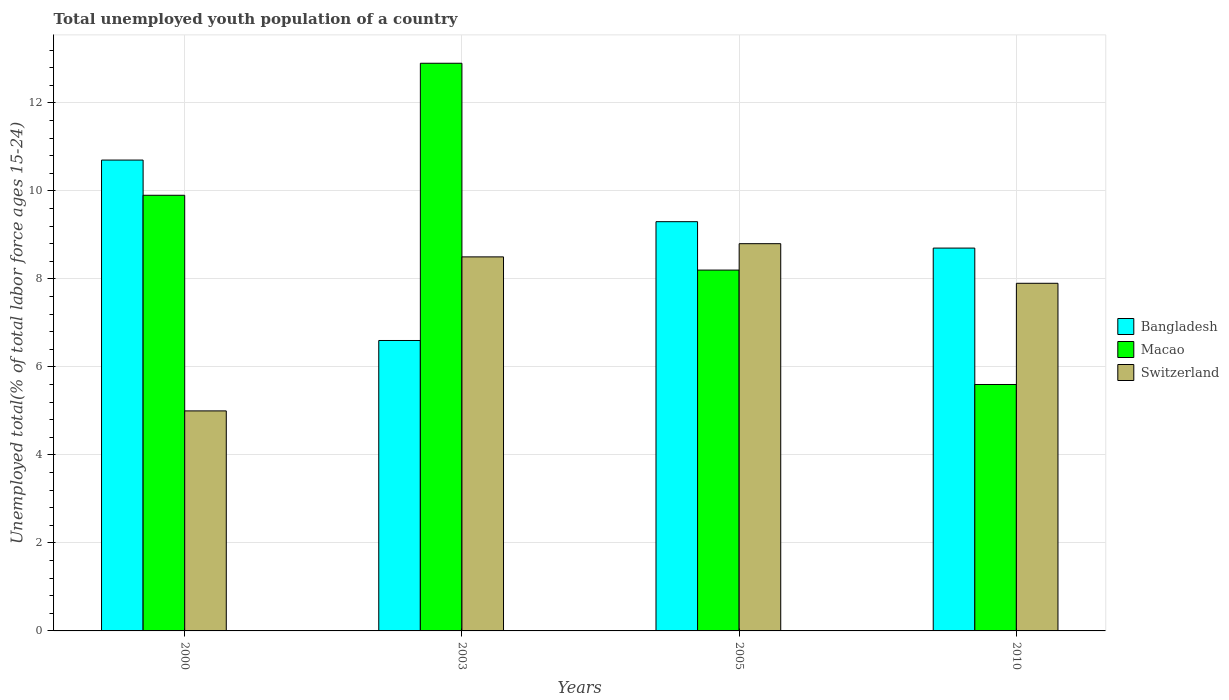How many different coloured bars are there?
Provide a short and direct response. 3. Are the number of bars per tick equal to the number of legend labels?
Provide a short and direct response. Yes. What is the percentage of total unemployed youth population of a country in Switzerland in 2003?
Your response must be concise. 8.5. Across all years, what is the maximum percentage of total unemployed youth population of a country in Switzerland?
Keep it short and to the point. 8.8. Across all years, what is the minimum percentage of total unemployed youth population of a country in Bangladesh?
Provide a short and direct response. 6.6. In which year was the percentage of total unemployed youth population of a country in Switzerland minimum?
Your answer should be very brief. 2000. What is the total percentage of total unemployed youth population of a country in Macao in the graph?
Your response must be concise. 36.6. What is the difference between the percentage of total unemployed youth population of a country in Macao in 2000 and that in 2005?
Provide a succinct answer. 1.7. What is the difference between the percentage of total unemployed youth population of a country in Macao in 2000 and the percentage of total unemployed youth population of a country in Switzerland in 2010?
Provide a succinct answer. 2. What is the average percentage of total unemployed youth population of a country in Switzerland per year?
Provide a succinct answer. 7.55. In the year 2003, what is the difference between the percentage of total unemployed youth population of a country in Bangladesh and percentage of total unemployed youth population of a country in Switzerland?
Keep it short and to the point. -1.9. In how many years, is the percentage of total unemployed youth population of a country in Switzerland greater than 5.6 %?
Provide a succinct answer. 3. What is the ratio of the percentage of total unemployed youth population of a country in Macao in 2000 to that in 2010?
Your response must be concise. 1.77. What is the difference between the highest and the second highest percentage of total unemployed youth population of a country in Bangladesh?
Provide a succinct answer. 1.4. What is the difference between the highest and the lowest percentage of total unemployed youth population of a country in Switzerland?
Offer a very short reply. 3.8. What does the 1st bar from the left in 2005 represents?
Your answer should be very brief. Bangladesh. What does the 2nd bar from the right in 2005 represents?
Provide a succinct answer. Macao. How many bars are there?
Offer a terse response. 12. Are all the bars in the graph horizontal?
Offer a terse response. No. Does the graph contain any zero values?
Your response must be concise. No. Does the graph contain grids?
Offer a terse response. Yes. Where does the legend appear in the graph?
Offer a very short reply. Center right. How are the legend labels stacked?
Give a very brief answer. Vertical. What is the title of the graph?
Ensure brevity in your answer.  Total unemployed youth population of a country. What is the label or title of the X-axis?
Provide a succinct answer. Years. What is the label or title of the Y-axis?
Ensure brevity in your answer.  Unemployed total(% of total labor force ages 15-24). What is the Unemployed total(% of total labor force ages 15-24) of Bangladesh in 2000?
Your answer should be compact. 10.7. What is the Unemployed total(% of total labor force ages 15-24) of Macao in 2000?
Keep it short and to the point. 9.9. What is the Unemployed total(% of total labor force ages 15-24) in Switzerland in 2000?
Offer a terse response. 5. What is the Unemployed total(% of total labor force ages 15-24) of Bangladesh in 2003?
Your answer should be very brief. 6.6. What is the Unemployed total(% of total labor force ages 15-24) of Macao in 2003?
Ensure brevity in your answer.  12.9. What is the Unemployed total(% of total labor force ages 15-24) of Bangladesh in 2005?
Your answer should be compact. 9.3. What is the Unemployed total(% of total labor force ages 15-24) of Macao in 2005?
Your answer should be very brief. 8.2. What is the Unemployed total(% of total labor force ages 15-24) in Switzerland in 2005?
Provide a short and direct response. 8.8. What is the Unemployed total(% of total labor force ages 15-24) of Bangladesh in 2010?
Give a very brief answer. 8.7. What is the Unemployed total(% of total labor force ages 15-24) in Macao in 2010?
Provide a short and direct response. 5.6. What is the Unemployed total(% of total labor force ages 15-24) in Switzerland in 2010?
Provide a short and direct response. 7.9. Across all years, what is the maximum Unemployed total(% of total labor force ages 15-24) of Bangladesh?
Keep it short and to the point. 10.7. Across all years, what is the maximum Unemployed total(% of total labor force ages 15-24) in Macao?
Provide a succinct answer. 12.9. Across all years, what is the maximum Unemployed total(% of total labor force ages 15-24) of Switzerland?
Offer a terse response. 8.8. Across all years, what is the minimum Unemployed total(% of total labor force ages 15-24) of Bangladesh?
Make the answer very short. 6.6. Across all years, what is the minimum Unemployed total(% of total labor force ages 15-24) in Macao?
Offer a very short reply. 5.6. Across all years, what is the minimum Unemployed total(% of total labor force ages 15-24) in Switzerland?
Offer a very short reply. 5. What is the total Unemployed total(% of total labor force ages 15-24) in Bangladesh in the graph?
Make the answer very short. 35.3. What is the total Unemployed total(% of total labor force ages 15-24) in Macao in the graph?
Your answer should be very brief. 36.6. What is the total Unemployed total(% of total labor force ages 15-24) in Switzerland in the graph?
Provide a succinct answer. 30.2. What is the difference between the Unemployed total(% of total labor force ages 15-24) of Bangladesh in 2000 and that in 2005?
Provide a succinct answer. 1.4. What is the difference between the Unemployed total(% of total labor force ages 15-24) of Macao in 2000 and that in 2005?
Your response must be concise. 1.7. What is the difference between the Unemployed total(% of total labor force ages 15-24) in Switzerland in 2000 and that in 2005?
Ensure brevity in your answer.  -3.8. What is the difference between the Unemployed total(% of total labor force ages 15-24) of Bangladesh in 2000 and that in 2010?
Offer a very short reply. 2. What is the difference between the Unemployed total(% of total labor force ages 15-24) in Macao in 2000 and that in 2010?
Offer a terse response. 4.3. What is the difference between the Unemployed total(% of total labor force ages 15-24) of Switzerland in 2003 and that in 2005?
Ensure brevity in your answer.  -0.3. What is the difference between the Unemployed total(% of total labor force ages 15-24) of Macao in 2003 and that in 2010?
Provide a succinct answer. 7.3. What is the difference between the Unemployed total(% of total labor force ages 15-24) of Switzerland in 2003 and that in 2010?
Provide a short and direct response. 0.6. What is the difference between the Unemployed total(% of total labor force ages 15-24) of Bangladesh in 2005 and that in 2010?
Keep it short and to the point. 0.6. What is the difference between the Unemployed total(% of total labor force ages 15-24) of Bangladesh in 2000 and the Unemployed total(% of total labor force ages 15-24) of Switzerland in 2003?
Offer a terse response. 2.2. What is the difference between the Unemployed total(% of total labor force ages 15-24) of Macao in 2000 and the Unemployed total(% of total labor force ages 15-24) of Switzerland in 2003?
Your answer should be very brief. 1.4. What is the difference between the Unemployed total(% of total labor force ages 15-24) in Bangladesh in 2000 and the Unemployed total(% of total labor force ages 15-24) in Macao in 2005?
Your response must be concise. 2.5. What is the difference between the Unemployed total(% of total labor force ages 15-24) in Bangladesh in 2000 and the Unemployed total(% of total labor force ages 15-24) in Switzerland in 2005?
Make the answer very short. 1.9. What is the difference between the Unemployed total(% of total labor force ages 15-24) in Bangladesh in 2000 and the Unemployed total(% of total labor force ages 15-24) in Macao in 2010?
Your response must be concise. 5.1. What is the difference between the Unemployed total(% of total labor force ages 15-24) in Bangladesh in 2000 and the Unemployed total(% of total labor force ages 15-24) in Switzerland in 2010?
Offer a terse response. 2.8. What is the difference between the Unemployed total(% of total labor force ages 15-24) of Macao in 2000 and the Unemployed total(% of total labor force ages 15-24) of Switzerland in 2010?
Your answer should be compact. 2. What is the difference between the Unemployed total(% of total labor force ages 15-24) of Bangladesh in 2003 and the Unemployed total(% of total labor force ages 15-24) of Macao in 2005?
Keep it short and to the point. -1.6. What is the difference between the Unemployed total(% of total labor force ages 15-24) of Bangladesh in 2003 and the Unemployed total(% of total labor force ages 15-24) of Switzerland in 2005?
Make the answer very short. -2.2. What is the difference between the Unemployed total(% of total labor force ages 15-24) of Macao in 2003 and the Unemployed total(% of total labor force ages 15-24) of Switzerland in 2005?
Your answer should be very brief. 4.1. What is the difference between the Unemployed total(% of total labor force ages 15-24) of Bangladesh in 2003 and the Unemployed total(% of total labor force ages 15-24) of Switzerland in 2010?
Ensure brevity in your answer.  -1.3. What is the difference between the Unemployed total(% of total labor force ages 15-24) in Bangladesh in 2005 and the Unemployed total(% of total labor force ages 15-24) in Macao in 2010?
Give a very brief answer. 3.7. What is the difference between the Unemployed total(% of total labor force ages 15-24) in Bangladesh in 2005 and the Unemployed total(% of total labor force ages 15-24) in Switzerland in 2010?
Your answer should be very brief. 1.4. What is the difference between the Unemployed total(% of total labor force ages 15-24) in Macao in 2005 and the Unemployed total(% of total labor force ages 15-24) in Switzerland in 2010?
Your answer should be compact. 0.3. What is the average Unemployed total(% of total labor force ages 15-24) of Bangladesh per year?
Offer a terse response. 8.82. What is the average Unemployed total(% of total labor force ages 15-24) of Macao per year?
Give a very brief answer. 9.15. What is the average Unemployed total(% of total labor force ages 15-24) of Switzerland per year?
Provide a succinct answer. 7.55. In the year 2000, what is the difference between the Unemployed total(% of total labor force ages 15-24) of Bangladesh and Unemployed total(% of total labor force ages 15-24) of Switzerland?
Provide a succinct answer. 5.7. In the year 2000, what is the difference between the Unemployed total(% of total labor force ages 15-24) of Macao and Unemployed total(% of total labor force ages 15-24) of Switzerland?
Your answer should be compact. 4.9. In the year 2003, what is the difference between the Unemployed total(% of total labor force ages 15-24) in Bangladesh and Unemployed total(% of total labor force ages 15-24) in Switzerland?
Keep it short and to the point. -1.9. In the year 2005, what is the difference between the Unemployed total(% of total labor force ages 15-24) of Bangladesh and Unemployed total(% of total labor force ages 15-24) of Macao?
Offer a very short reply. 1.1. In the year 2005, what is the difference between the Unemployed total(% of total labor force ages 15-24) of Bangladesh and Unemployed total(% of total labor force ages 15-24) of Switzerland?
Your response must be concise. 0.5. In the year 2005, what is the difference between the Unemployed total(% of total labor force ages 15-24) of Macao and Unemployed total(% of total labor force ages 15-24) of Switzerland?
Your answer should be very brief. -0.6. In the year 2010, what is the difference between the Unemployed total(% of total labor force ages 15-24) of Bangladesh and Unemployed total(% of total labor force ages 15-24) of Macao?
Provide a short and direct response. 3.1. In the year 2010, what is the difference between the Unemployed total(% of total labor force ages 15-24) in Macao and Unemployed total(% of total labor force ages 15-24) in Switzerland?
Provide a short and direct response. -2.3. What is the ratio of the Unemployed total(% of total labor force ages 15-24) in Bangladesh in 2000 to that in 2003?
Provide a succinct answer. 1.62. What is the ratio of the Unemployed total(% of total labor force ages 15-24) in Macao in 2000 to that in 2003?
Provide a succinct answer. 0.77. What is the ratio of the Unemployed total(% of total labor force ages 15-24) in Switzerland in 2000 to that in 2003?
Offer a very short reply. 0.59. What is the ratio of the Unemployed total(% of total labor force ages 15-24) in Bangladesh in 2000 to that in 2005?
Keep it short and to the point. 1.15. What is the ratio of the Unemployed total(% of total labor force ages 15-24) in Macao in 2000 to that in 2005?
Your answer should be compact. 1.21. What is the ratio of the Unemployed total(% of total labor force ages 15-24) of Switzerland in 2000 to that in 2005?
Ensure brevity in your answer.  0.57. What is the ratio of the Unemployed total(% of total labor force ages 15-24) of Bangladesh in 2000 to that in 2010?
Your answer should be compact. 1.23. What is the ratio of the Unemployed total(% of total labor force ages 15-24) of Macao in 2000 to that in 2010?
Your answer should be compact. 1.77. What is the ratio of the Unemployed total(% of total labor force ages 15-24) in Switzerland in 2000 to that in 2010?
Your answer should be compact. 0.63. What is the ratio of the Unemployed total(% of total labor force ages 15-24) of Bangladesh in 2003 to that in 2005?
Your answer should be compact. 0.71. What is the ratio of the Unemployed total(% of total labor force ages 15-24) of Macao in 2003 to that in 2005?
Your response must be concise. 1.57. What is the ratio of the Unemployed total(% of total labor force ages 15-24) of Switzerland in 2003 to that in 2005?
Provide a short and direct response. 0.97. What is the ratio of the Unemployed total(% of total labor force ages 15-24) in Bangladesh in 2003 to that in 2010?
Keep it short and to the point. 0.76. What is the ratio of the Unemployed total(% of total labor force ages 15-24) of Macao in 2003 to that in 2010?
Provide a short and direct response. 2.3. What is the ratio of the Unemployed total(% of total labor force ages 15-24) of Switzerland in 2003 to that in 2010?
Make the answer very short. 1.08. What is the ratio of the Unemployed total(% of total labor force ages 15-24) in Bangladesh in 2005 to that in 2010?
Give a very brief answer. 1.07. What is the ratio of the Unemployed total(% of total labor force ages 15-24) of Macao in 2005 to that in 2010?
Make the answer very short. 1.46. What is the ratio of the Unemployed total(% of total labor force ages 15-24) in Switzerland in 2005 to that in 2010?
Provide a short and direct response. 1.11. What is the difference between the highest and the second highest Unemployed total(% of total labor force ages 15-24) in Bangladesh?
Offer a very short reply. 1.4. What is the difference between the highest and the second highest Unemployed total(% of total labor force ages 15-24) of Switzerland?
Provide a succinct answer. 0.3. What is the difference between the highest and the lowest Unemployed total(% of total labor force ages 15-24) of Macao?
Keep it short and to the point. 7.3. 